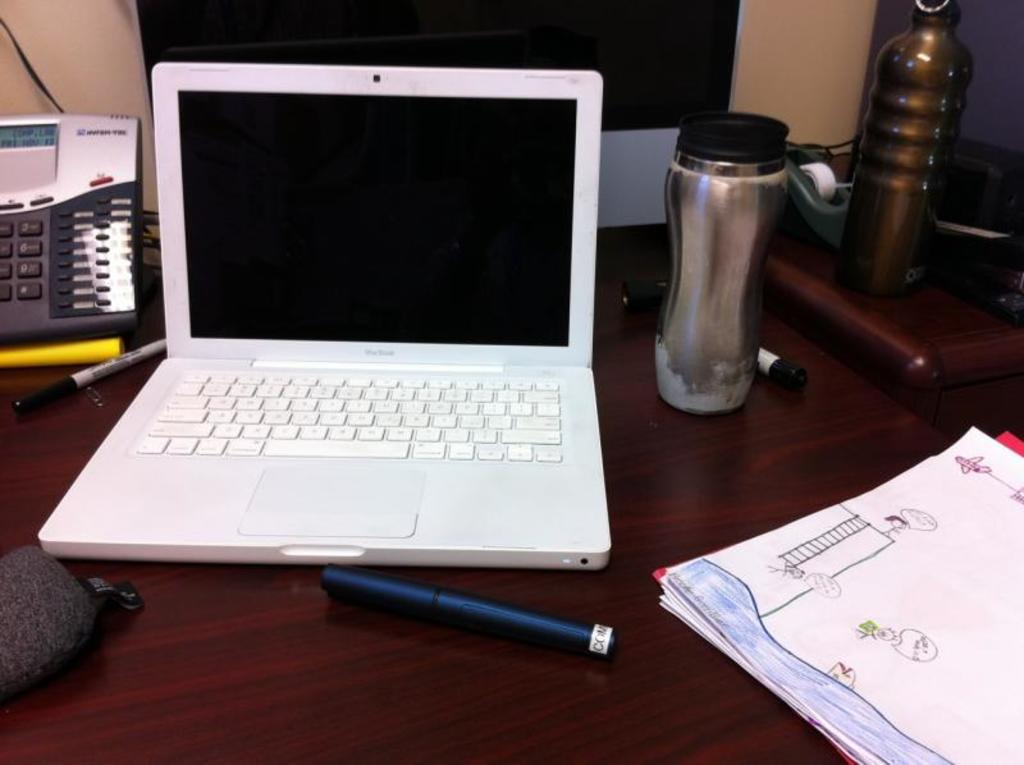What electronic device is visible in the image? There is a laptop in the image. What stationary items can be seen in the image? There are pens, papers, and bottles visible in the image. What communication device is present in the image? There is a telephone in the image. What type of plastic animal can be seen in the image? There is no plastic animal present in the image. Can you tell me how many jars are visible in the image? There is no jar present in the image. 